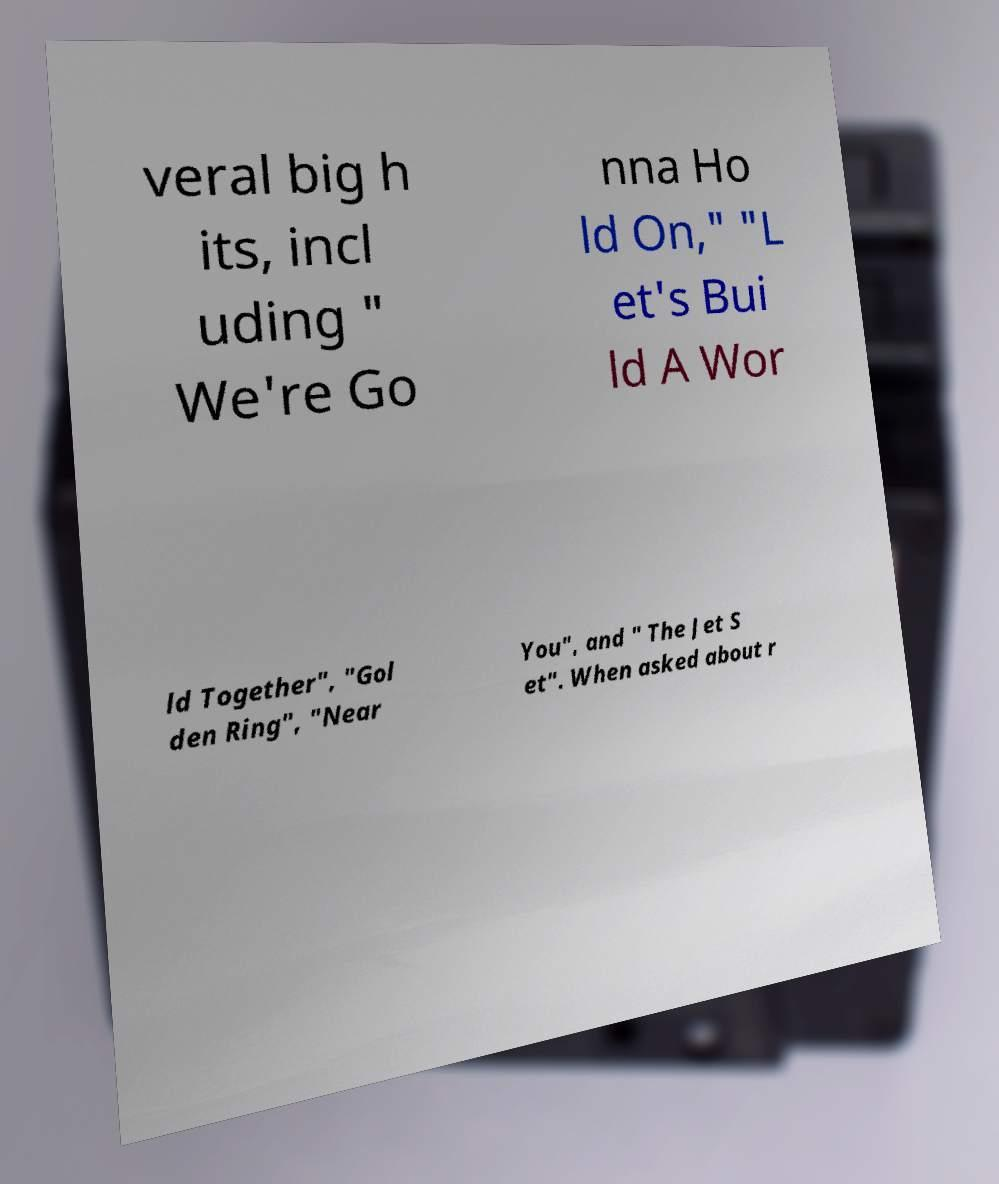Could you extract and type out the text from this image? veral big h its, incl uding " We're Go nna Ho ld On," "L et's Bui ld A Wor ld Together", "Gol den Ring", "Near You", and " The Jet S et". When asked about r 